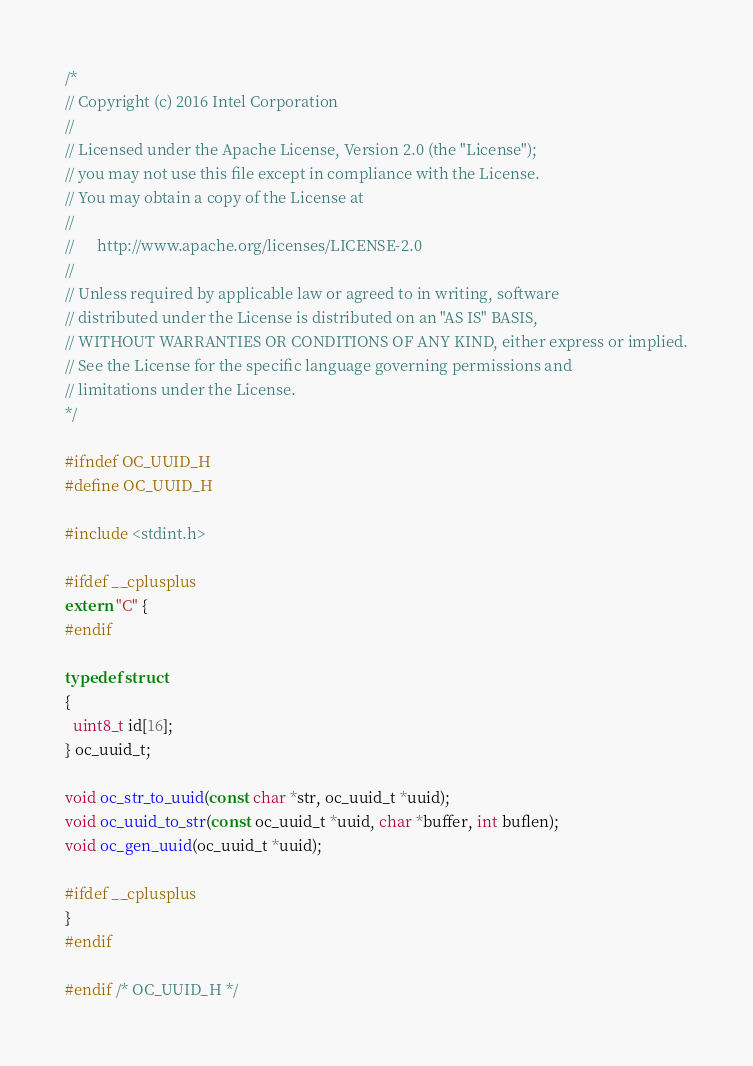<code> <loc_0><loc_0><loc_500><loc_500><_C_>/*
// Copyright (c) 2016 Intel Corporation
//
// Licensed under the Apache License, Version 2.0 (the "License");
// you may not use this file except in compliance with the License.
// You may obtain a copy of the License at
//
//      http://www.apache.org/licenses/LICENSE-2.0
//
// Unless required by applicable law or agreed to in writing, software
// distributed under the License is distributed on an "AS IS" BASIS,
// WITHOUT WARRANTIES OR CONDITIONS OF ANY KIND, either express or implied.
// See the License for the specific language governing permissions and
// limitations under the License.
*/

#ifndef OC_UUID_H
#define OC_UUID_H

#include <stdint.h>

#ifdef __cplusplus
extern "C" {
#endif

typedef struct
{
  uint8_t id[16];
} oc_uuid_t;

void oc_str_to_uuid(const char *str, oc_uuid_t *uuid);
void oc_uuid_to_str(const oc_uuid_t *uuid, char *buffer, int buflen);
void oc_gen_uuid(oc_uuid_t *uuid);

#ifdef __cplusplus
}
#endif

#endif /* OC_UUID_H */
</code> 